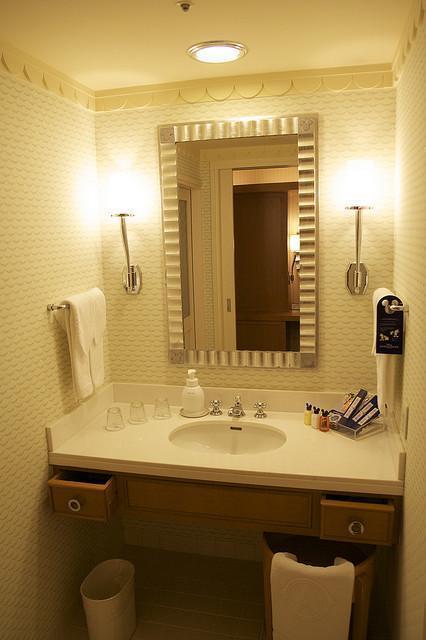Who provides the bottles on the counter?
Answer the question by selecting the correct answer among the 4 following choices.
Options: House guest, homeowner, hotel, customer. Hotel. 